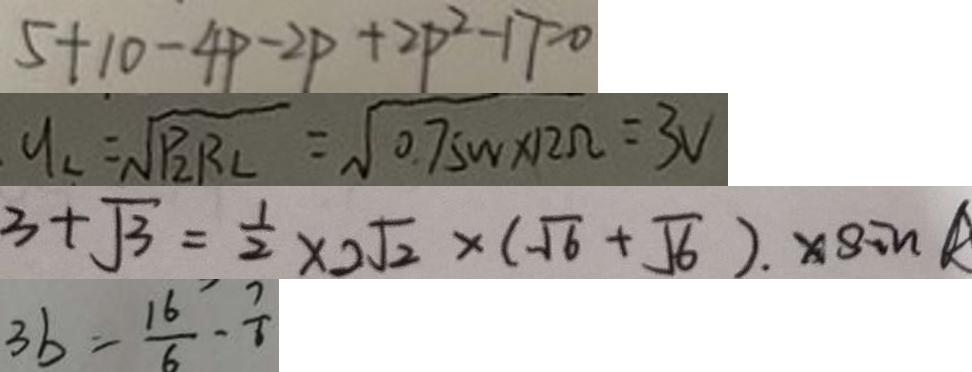Convert formula to latex. <formula><loc_0><loc_0><loc_500><loc_500>5 + 1 0 - 4 p - 2 P + 2 p ^ { 2 } - 1 7 = 0 
 y _ { 2 } = \sqrt { P _ { 2 } R _ { 2 } } = \sqrt { 0 . 7 5 W \times 1 2 \Omega } = 3 V 
 3 + \sqrt { 3 } = \frac { 1 } { 2 } \times 2 \sqrt { 2 } \times ( \sqrt { 6 } + \sqrt { 6 } ) . \times \sin R 
 3 b = \frac { 1 6 } { 6 } - \frac { 7 } { 6 }</formula> 